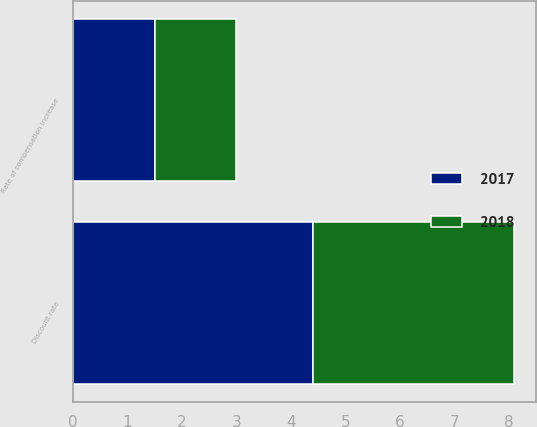Convert chart to OTSL. <chart><loc_0><loc_0><loc_500><loc_500><stacked_bar_chart><ecel><fcel>Discount rate<fcel>Rate of compensation increase<nl><fcel>2017<fcel>4.4<fcel>1.5<nl><fcel>2018<fcel>3.7<fcel>1.5<nl></chart> 